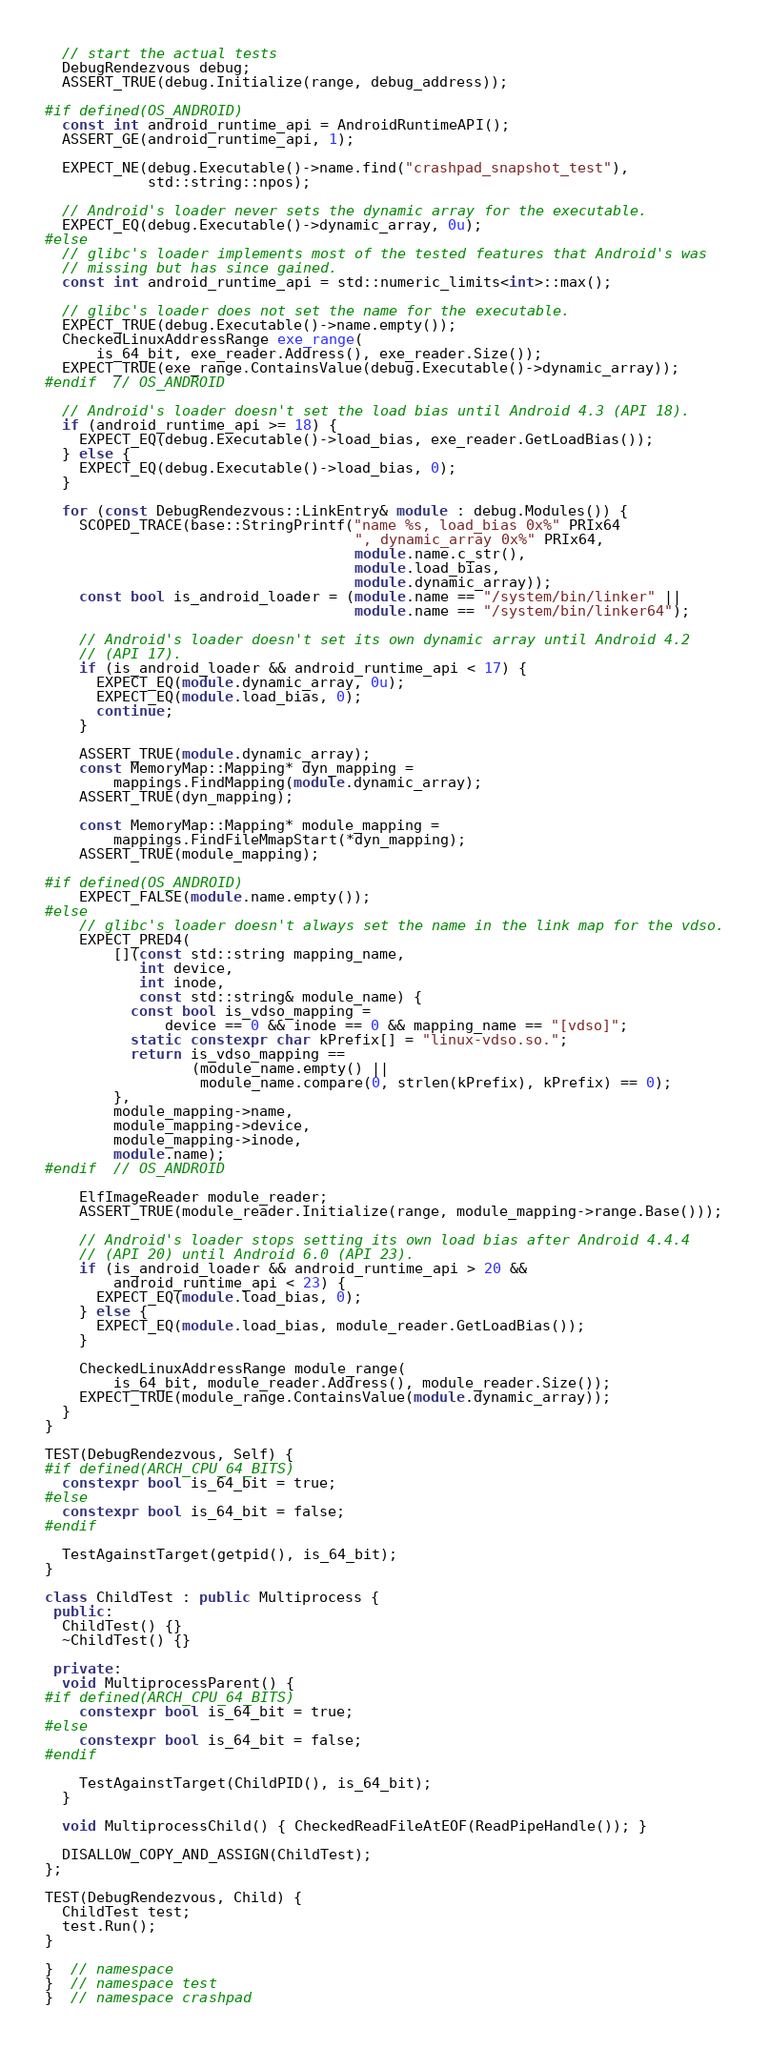<code> <loc_0><loc_0><loc_500><loc_500><_C++_>  // start the actual tests
  DebugRendezvous debug;
  ASSERT_TRUE(debug.Initialize(range, debug_address));

#if defined(OS_ANDROID)
  const int android_runtime_api = AndroidRuntimeAPI();
  ASSERT_GE(android_runtime_api, 1);

  EXPECT_NE(debug.Executable()->name.find("crashpad_snapshot_test"),
            std::string::npos);

  // Android's loader never sets the dynamic array for the executable.
  EXPECT_EQ(debug.Executable()->dynamic_array, 0u);
#else
  // glibc's loader implements most of the tested features that Android's was
  // missing but has since gained.
  const int android_runtime_api = std::numeric_limits<int>::max();

  // glibc's loader does not set the name for the executable.
  EXPECT_TRUE(debug.Executable()->name.empty());
  CheckedLinuxAddressRange exe_range(
      is_64_bit, exe_reader.Address(), exe_reader.Size());
  EXPECT_TRUE(exe_range.ContainsValue(debug.Executable()->dynamic_array));
#endif  // OS_ANDROID

  // Android's loader doesn't set the load bias until Android 4.3 (API 18).
  if (android_runtime_api >= 18) {
    EXPECT_EQ(debug.Executable()->load_bias, exe_reader.GetLoadBias());
  } else {
    EXPECT_EQ(debug.Executable()->load_bias, 0);
  }

  for (const DebugRendezvous::LinkEntry& module : debug.Modules()) {
    SCOPED_TRACE(base::StringPrintf("name %s, load_bias 0x%" PRIx64
                                    ", dynamic_array 0x%" PRIx64,
                                    module.name.c_str(),
                                    module.load_bias,
                                    module.dynamic_array));
    const bool is_android_loader = (module.name == "/system/bin/linker" ||
                                    module.name == "/system/bin/linker64");

    // Android's loader doesn't set its own dynamic array until Android 4.2
    // (API 17).
    if (is_android_loader && android_runtime_api < 17) {
      EXPECT_EQ(module.dynamic_array, 0u);
      EXPECT_EQ(module.load_bias, 0);
      continue;
    }

    ASSERT_TRUE(module.dynamic_array);
    const MemoryMap::Mapping* dyn_mapping =
        mappings.FindMapping(module.dynamic_array);
    ASSERT_TRUE(dyn_mapping);

    const MemoryMap::Mapping* module_mapping =
        mappings.FindFileMmapStart(*dyn_mapping);
    ASSERT_TRUE(module_mapping);

#if defined(OS_ANDROID)
    EXPECT_FALSE(module.name.empty());
#else
    // glibc's loader doesn't always set the name in the link map for the vdso.
    EXPECT_PRED4(
        [](const std::string mapping_name,
           int device,
           int inode,
           const std::string& module_name) {
          const bool is_vdso_mapping =
              device == 0 && inode == 0 && mapping_name == "[vdso]";
          static constexpr char kPrefix[] = "linux-vdso.so.";
          return is_vdso_mapping ==
                 (module_name.empty() ||
                  module_name.compare(0, strlen(kPrefix), kPrefix) == 0);
        },
        module_mapping->name,
        module_mapping->device,
        module_mapping->inode,
        module.name);
#endif  // OS_ANDROID

    ElfImageReader module_reader;
    ASSERT_TRUE(module_reader.Initialize(range, module_mapping->range.Base()));

    // Android's loader stops setting its own load bias after Android 4.4.4
    // (API 20) until Android 6.0 (API 23).
    if (is_android_loader && android_runtime_api > 20 &&
        android_runtime_api < 23) {
      EXPECT_EQ(module.load_bias, 0);
    } else {
      EXPECT_EQ(module.load_bias, module_reader.GetLoadBias());
    }

    CheckedLinuxAddressRange module_range(
        is_64_bit, module_reader.Address(), module_reader.Size());
    EXPECT_TRUE(module_range.ContainsValue(module.dynamic_array));
  }
}

TEST(DebugRendezvous, Self) {
#if defined(ARCH_CPU_64_BITS)
  constexpr bool is_64_bit = true;
#else
  constexpr bool is_64_bit = false;
#endif

  TestAgainstTarget(getpid(), is_64_bit);
}

class ChildTest : public Multiprocess {
 public:
  ChildTest() {}
  ~ChildTest() {}

 private:
  void MultiprocessParent() {
#if defined(ARCH_CPU_64_BITS)
    constexpr bool is_64_bit = true;
#else
    constexpr bool is_64_bit = false;
#endif

    TestAgainstTarget(ChildPID(), is_64_bit);
  }

  void MultiprocessChild() { CheckedReadFileAtEOF(ReadPipeHandle()); }

  DISALLOW_COPY_AND_ASSIGN(ChildTest);
};

TEST(DebugRendezvous, Child) {
  ChildTest test;
  test.Run();
}

}  // namespace
}  // namespace test
}  // namespace crashpad
</code> 